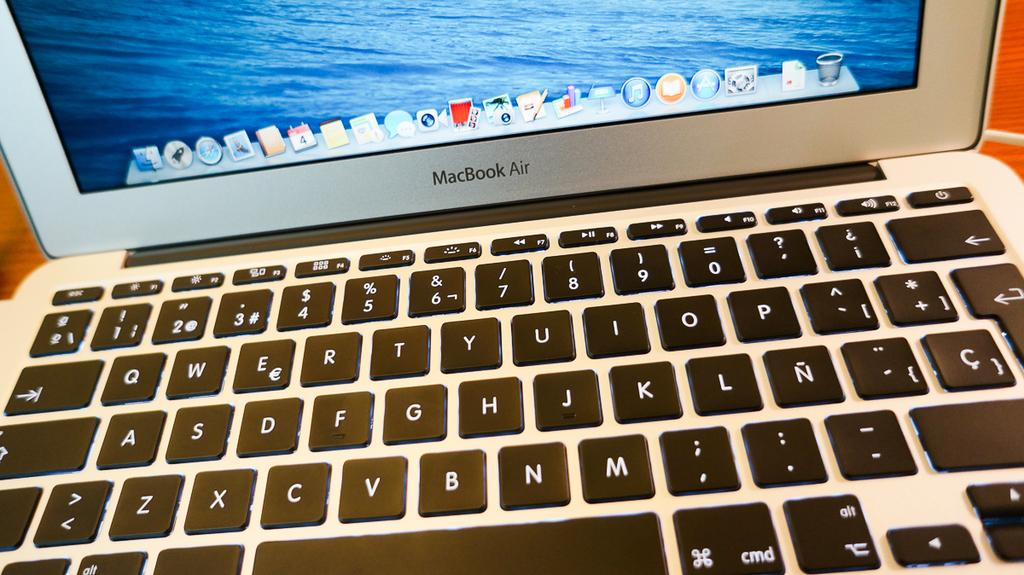<image>
Create a compact narrative representing the image presented. A closeup of the keyboard on a MacBook Air 